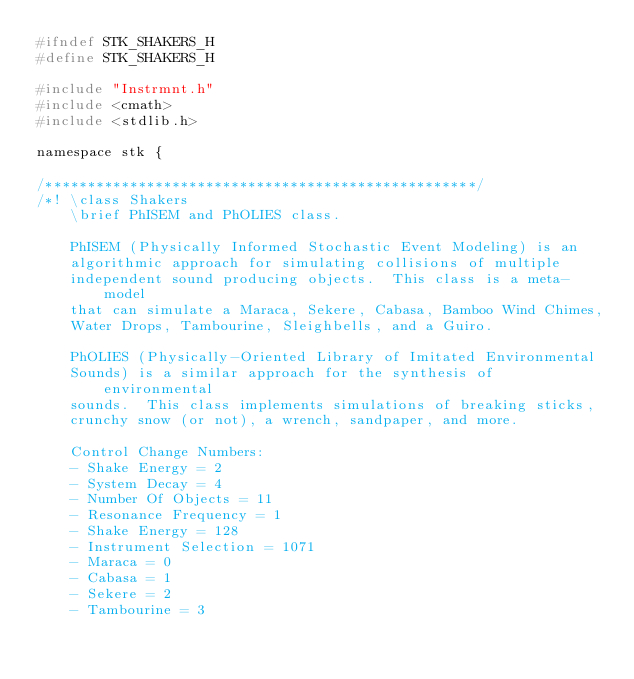Convert code to text. <code><loc_0><loc_0><loc_500><loc_500><_C_>#ifndef STK_SHAKERS_H
#define STK_SHAKERS_H

#include "Instrmnt.h"
#include <cmath>
#include <stdlib.h>

namespace stk {

/***************************************************/
/*! \class Shakers
    \brief PhISEM and PhOLIES class.

    PhISEM (Physically Informed Stochastic Event Modeling) is an
    algorithmic approach for simulating collisions of multiple
    independent sound producing objects.  This class is a meta-model
    that can simulate a Maraca, Sekere, Cabasa, Bamboo Wind Chimes,
    Water Drops, Tambourine, Sleighbells, and a Guiro.

    PhOLIES (Physically-Oriented Library of Imitated Environmental
    Sounds) is a similar approach for the synthesis of environmental
    sounds.  This class implements simulations of breaking sticks,
    crunchy snow (or not), a wrench, sandpaper, and more.

    Control Change Numbers: 
    - Shake Energy = 2
    - System Decay = 4
    - Number Of Objects = 11
    - Resonance Frequency = 1
    - Shake Energy = 128
    - Instrument Selection = 1071
    - Maraca = 0
    - Cabasa = 1
    - Sekere = 2
    - Tambourine = 3</code> 